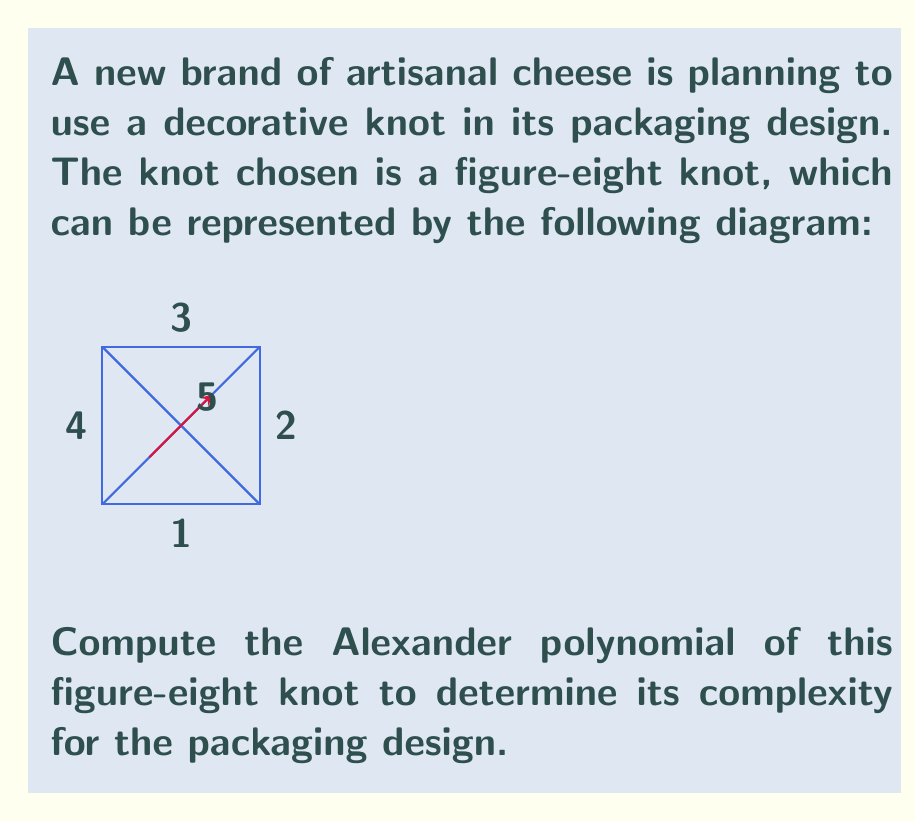Solve this math problem. To compute the Alexander polynomial of the figure-eight knot, we'll follow these steps:

1) First, we need to label the arcs and crossings. We've already done this in the diagram.

2) Now, we create a matrix based on the crossings. For each crossing, we'll have a row in the matrix. The columns represent the arcs.

3) For the figure-eight knot, we have the following matrix:

   $$\begin{pmatrix}
   1-t & -1 & 0 & t & 0 \\
   0 & 1-t & -1 & 0 & t \\
   t & 0 & 1-t & -1 & 0 \\
   -1 & t & 0 & 1-t & 0
   \end{pmatrix}$$

4) To find the Alexander polynomial, we need to calculate the determinant of any 3x3 minor of this matrix (removing any two columns).

5) Let's remove the last two columns. We get:

   $$\begin{vmatrix}
   1-t & -1 & 0 \\
   0 & 1-t & -1 \\
   t & 0 & 1-t
   \end{vmatrix}$$

6) Calculate this determinant:
   $$(1-t)((1-t)(1-t) - 0) - (-1)(0(1-t) - (-1)t) + 0$$
   $$= (1-t)(1-2t+t^2) + t$$
   $$= 1-2t+t^2-t+2t^2-t^3+t$$
   $$= 1-t+2t^2-t^3$$

7) The Alexander polynomial is the absolute value of this result:

   $$\Delta(t) = |1-t+2t^2-t^3|$$

This polynomial represents the complexity of the figure-eight knot in the packaging design.
Answer: $\Delta(t) = |1-t+2t^2-t^3|$ 